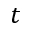Convert formula to latex. <formula><loc_0><loc_0><loc_500><loc_500>t</formula> 